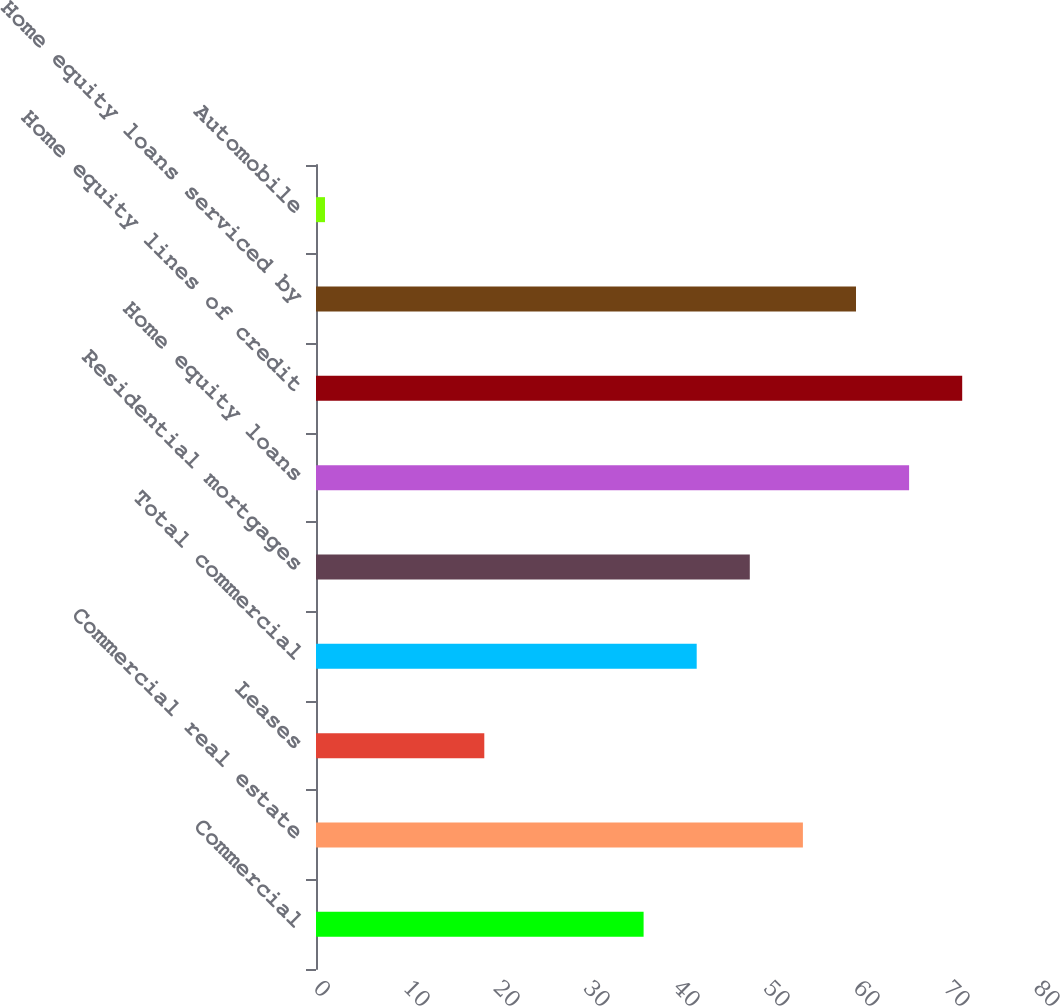<chart> <loc_0><loc_0><loc_500><loc_500><bar_chart><fcel>Commercial<fcel>Commercial real estate<fcel>Leases<fcel>Total commercial<fcel>Residential mortgages<fcel>Home equity loans<fcel>Home equity lines of credit<fcel>Home equity loans serviced by<fcel>Automobile<nl><fcel>36.4<fcel>54.1<fcel>18.7<fcel>42.3<fcel>48.2<fcel>65.9<fcel>71.8<fcel>60<fcel>1<nl></chart> 